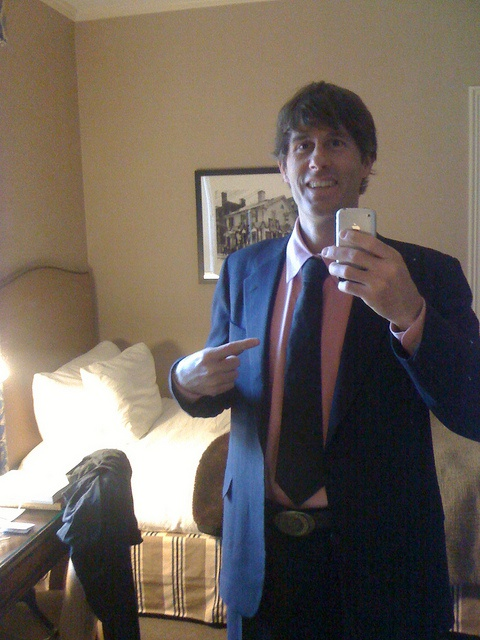Describe the objects in this image and their specific colors. I can see people in brown, black, gray, and navy tones, bed in brown, white, gray, and tan tones, tie in brown, black, navy, gray, and blue tones, chair in brown, black, and gray tones, and cell phone in brown and gray tones in this image. 